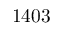Convert formula to latex. <formula><loc_0><loc_0><loc_500><loc_500>1 4 0 3</formula> 